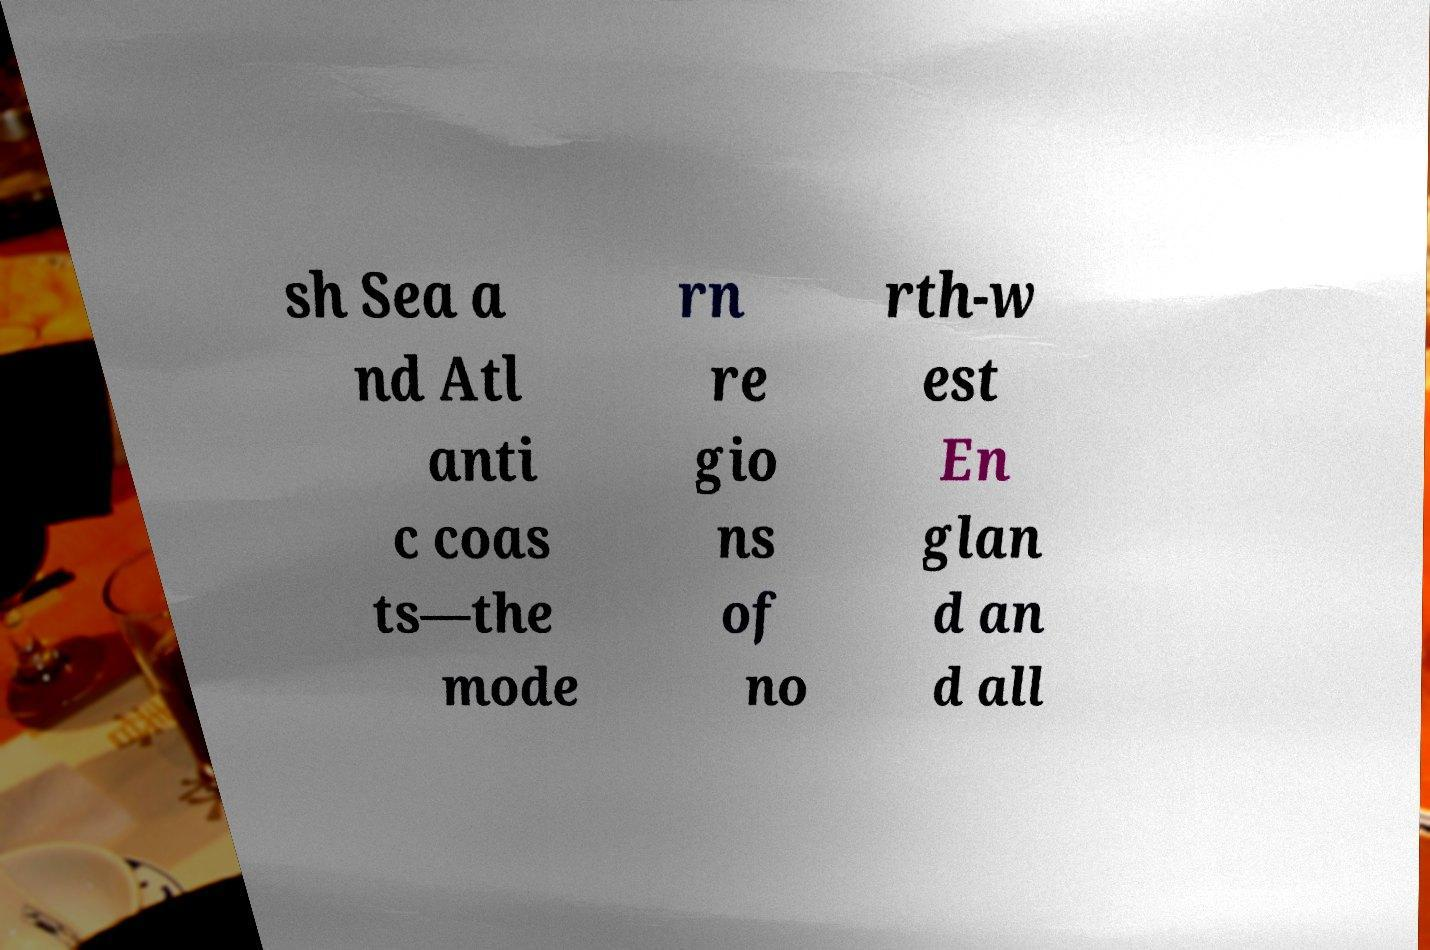For documentation purposes, I need the text within this image transcribed. Could you provide that? sh Sea a nd Atl anti c coas ts—the mode rn re gio ns of no rth-w est En glan d an d all 